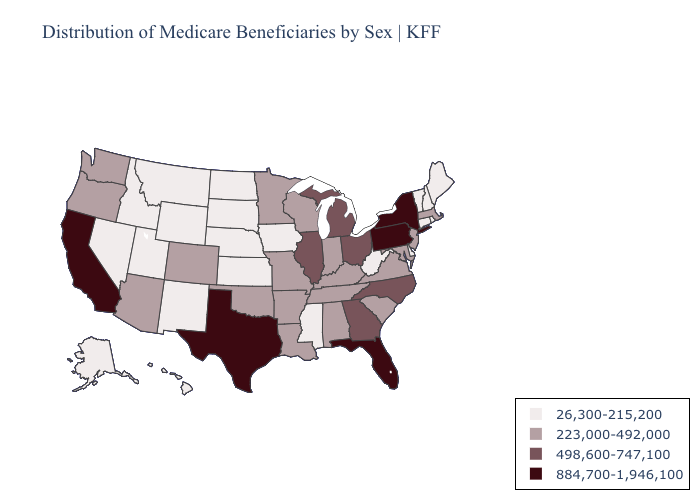What is the value of Kentucky?
Short answer required. 223,000-492,000. What is the value of Minnesota?
Short answer required. 223,000-492,000. Name the states that have a value in the range 498,600-747,100?
Answer briefly. Georgia, Illinois, Michigan, North Carolina, Ohio. What is the highest value in states that border Wisconsin?
Short answer required. 498,600-747,100. Does Massachusetts have the same value as Montana?
Quick response, please. No. Among the states that border Washington , does Oregon have the lowest value?
Be succinct. No. Name the states that have a value in the range 884,700-1,946,100?
Quick response, please. California, Florida, New York, Pennsylvania, Texas. What is the highest value in the USA?
Give a very brief answer. 884,700-1,946,100. Which states have the lowest value in the South?
Give a very brief answer. Delaware, Mississippi, West Virginia. Does Rhode Island have a higher value than Missouri?
Be succinct. No. What is the highest value in the West ?
Write a very short answer. 884,700-1,946,100. Does the first symbol in the legend represent the smallest category?
Give a very brief answer. Yes. Name the states that have a value in the range 498,600-747,100?
Be succinct. Georgia, Illinois, Michigan, North Carolina, Ohio. Name the states that have a value in the range 884,700-1,946,100?
Short answer required. California, Florida, New York, Pennsylvania, Texas. What is the value of Wisconsin?
Be succinct. 223,000-492,000. 